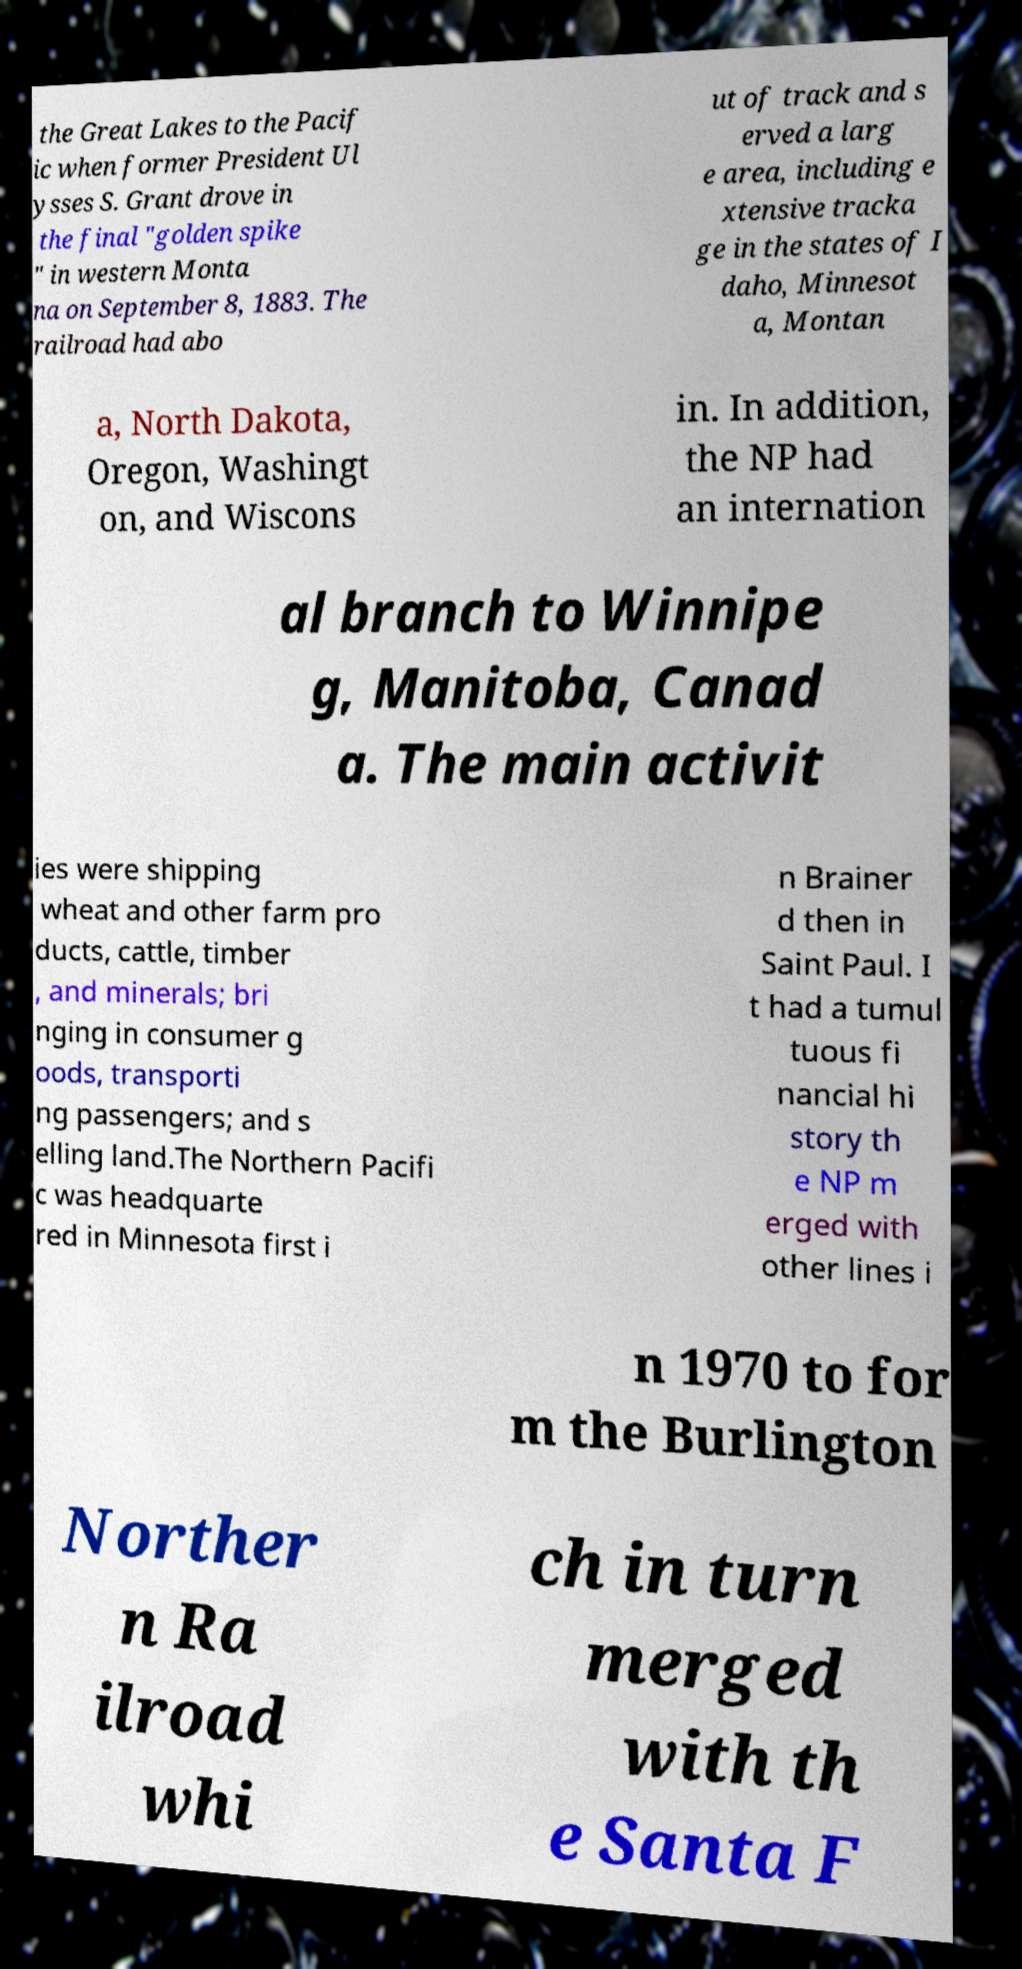Can you accurately transcribe the text from the provided image for me? the Great Lakes to the Pacif ic when former President Ul ysses S. Grant drove in the final "golden spike " in western Monta na on September 8, 1883. The railroad had abo ut of track and s erved a larg e area, including e xtensive tracka ge in the states of I daho, Minnesot a, Montan a, North Dakota, Oregon, Washingt on, and Wiscons in. In addition, the NP had an internation al branch to Winnipe g, Manitoba, Canad a. The main activit ies were shipping wheat and other farm pro ducts, cattle, timber , and minerals; bri nging in consumer g oods, transporti ng passengers; and s elling land.The Northern Pacifi c was headquarte red in Minnesota first i n Brainer d then in Saint Paul. I t had a tumul tuous fi nancial hi story th e NP m erged with other lines i n 1970 to for m the Burlington Norther n Ra ilroad whi ch in turn merged with th e Santa F 